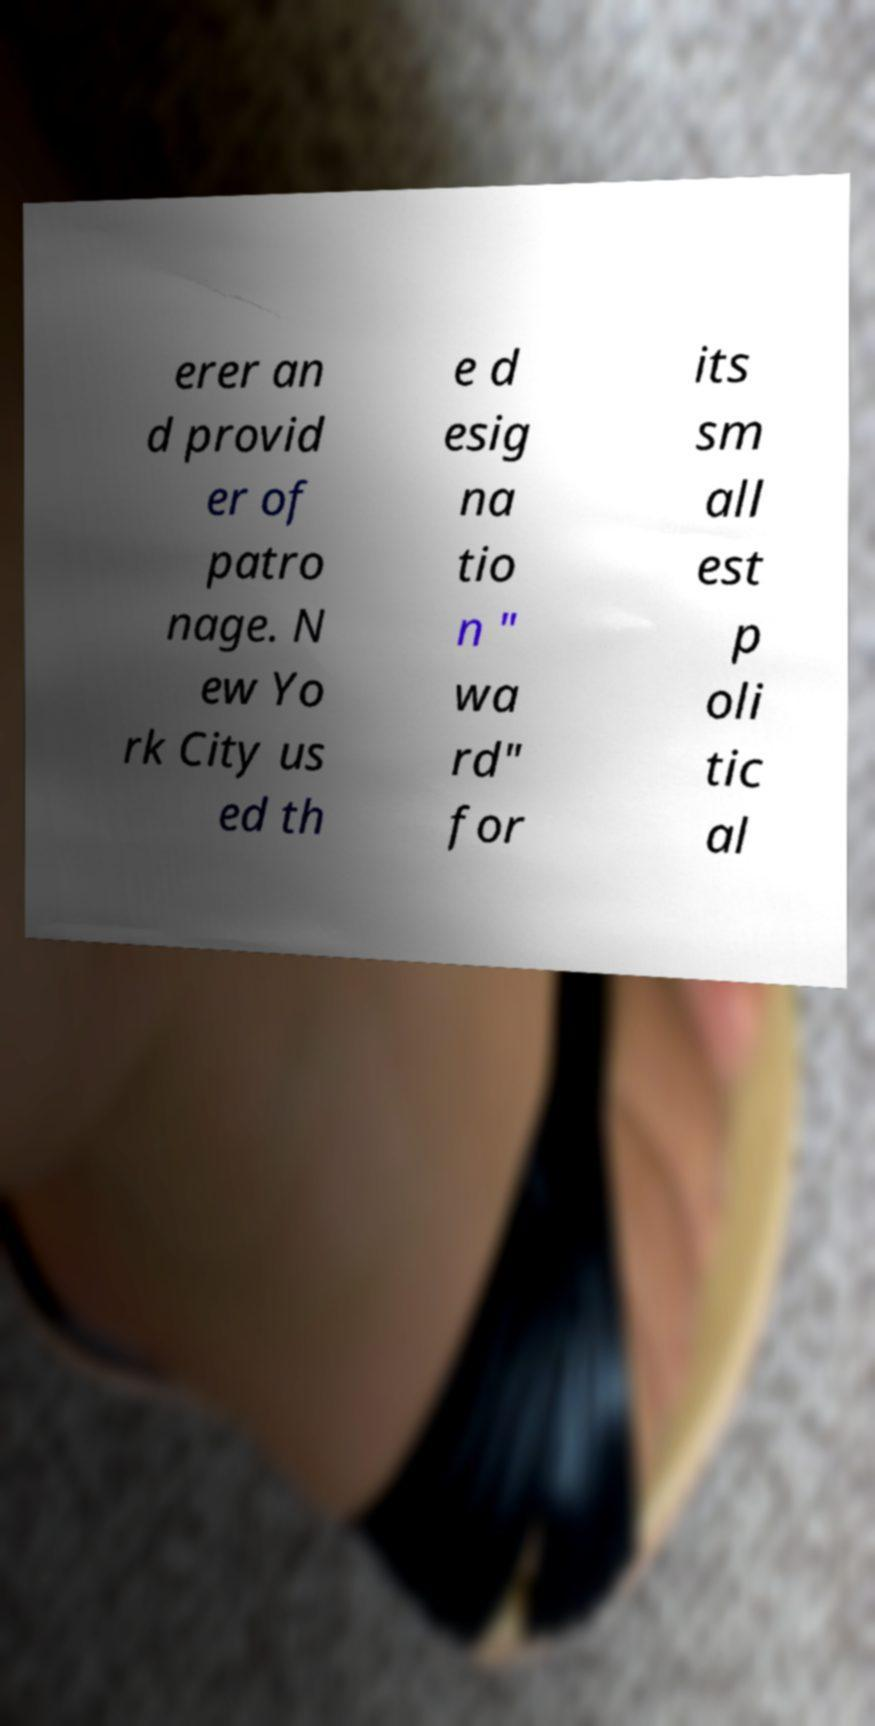For documentation purposes, I need the text within this image transcribed. Could you provide that? erer an d provid er of patro nage. N ew Yo rk City us ed th e d esig na tio n " wa rd" for its sm all est p oli tic al 